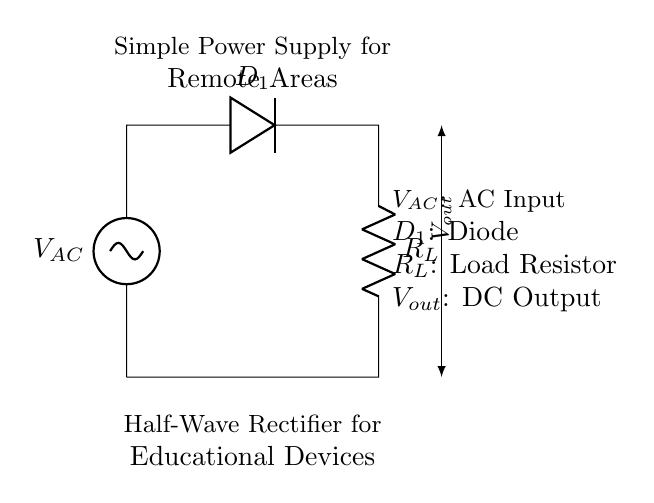What type of rectifier is shown in this circuit? The circuit diagram clearly indicates a half-wave rectifier by its configuration, using a single diode that allows current to pass during only one half of the AC cycle.
Answer: Half-wave What component is responsible for converting AC to DC in this circuit? The diode in the circuit diagram, labeled as D1, is the component that allows current to flow in one direction only, effectively converting AC to DC.
Answer: Diode What is the function of the load resistor in the circuit? The load resistor, labeled as R_L, receives the DC output from the rectifier and provides a path for current flow to any connected devices, representing the load in this rectifier application.
Answer: Load What voltage type is the input to this rectifier circuit? The input is labeled V_AC in the diagram, indicating that it is an alternating current (AC) voltage supply feeding the rectifier.
Answer: AC How many diodes are used in this half-wave rectifier circuit? The circuit has only one diode (D1) shown connecting the AC source to the load, which is characteristic of a half-wave rectifier design.
Answer: One What does the label V_out represent in this circuit? V_out represents the output voltage produced by the rectifier across the load, which is the DC voltage that powers the connected devices.
Answer: DC Output What is the expected flow of current in this circuit during the positive half of the AC cycle? During the positive half-cycle of the AC input, current will flow through the diode D1 to the load R_L, indicating that current is allowed to pass only at this time, blocking any reverse flow.
Answer: Forward flow 